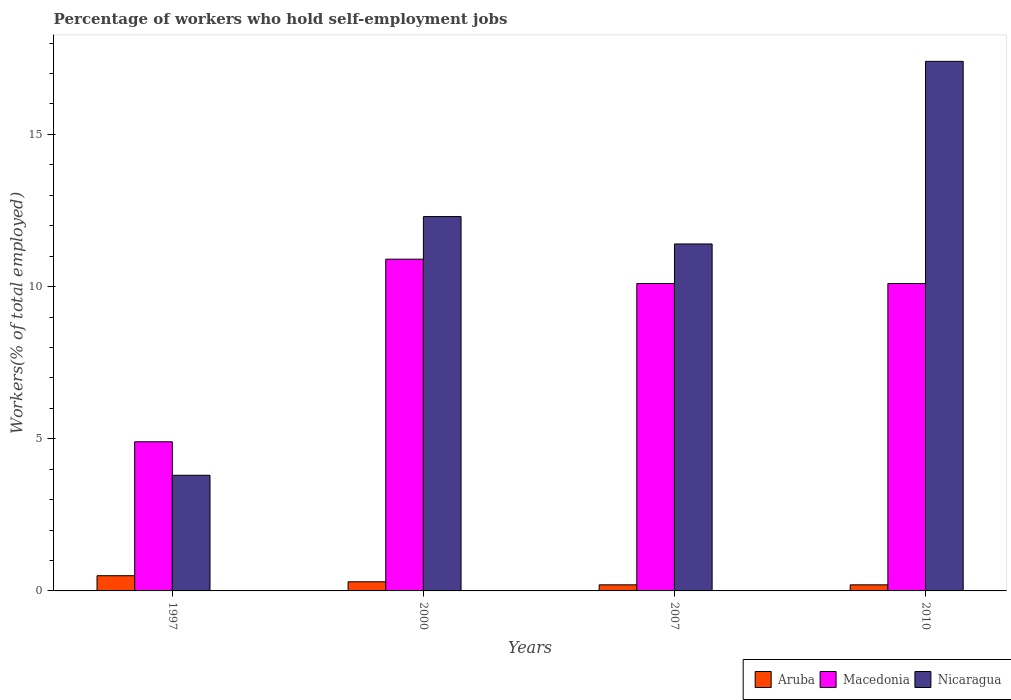How many different coloured bars are there?
Offer a terse response. 3. Are the number of bars per tick equal to the number of legend labels?
Your answer should be very brief. Yes. How many bars are there on the 1st tick from the right?
Your answer should be compact. 3. What is the label of the 3rd group of bars from the left?
Give a very brief answer. 2007. In how many cases, is the number of bars for a given year not equal to the number of legend labels?
Offer a very short reply. 0. What is the percentage of self-employed workers in Macedonia in 2000?
Give a very brief answer. 10.9. Across all years, what is the maximum percentage of self-employed workers in Macedonia?
Provide a short and direct response. 10.9. Across all years, what is the minimum percentage of self-employed workers in Aruba?
Offer a terse response. 0.2. What is the total percentage of self-employed workers in Nicaragua in the graph?
Your answer should be very brief. 44.9. What is the difference between the percentage of self-employed workers in Aruba in 2000 and that in 2010?
Your answer should be compact. 0.1. What is the difference between the percentage of self-employed workers in Nicaragua in 2007 and the percentage of self-employed workers in Aruba in 2000?
Your answer should be very brief. 11.1. What is the average percentage of self-employed workers in Aruba per year?
Provide a succinct answer. 0.3. In the year 2007, what is the difference between the percentage of self-employed workers in Nicaragua and percentage of self-employed workers in Macedonia?
Your response must be concise. 1.3. In how many years, is the percentage of self-employed workers in Macedonia greater than 5 %?
Make the answer very short. 3. What is the ratio of the percentage of self-employed workers in Nicaragua in 1997 to that in 2010?
Offer a very short reply. 0.22. Is the percentage of self-employed workers in Macedonia in 2000 less than that in 2007?
Offer a terse response. No. What is the difference between the highest and the second highest percentage of self-employed workers in Aruba?
Offer a terse response. 0.2. What is the difference between the highest and the lowest percentage of self-employed workers in Nicaragua?
Offer a very short reply. 13.6. What does the 1st bar from the left in 2010 represents?
Provide a short and direct response. Aruba. What does the 2nd bar from the right in 1997 represents?
Your answer should be compact. Macedonia. Does the graph contain grids?
Offer a very short reply. No. Where does the legend appear in the graph?
Give a very brief answer. Bottom right. What is the title of the graph?
Offer a very short reply. Percentage of workers who hold self-employment jobs. What is the label or title of the X-axis?
Make the answer very short. Years. What is the label or title of the Y-axis?
Offer a terse response. Workers(% of total employed). What is the Workers(% of total employed) of Aruba in 1997?
Make the answer very short. 0.5. What is the Workers(% of total employed) in Macedonia in 1997?
Keep it short and to the point. 4.9. What is the Workers(% of total employed) of Nicaragua in 1997?
Your answer should be very brief. 3.8. What is the Workers(% of total employed) in Aruba in 2000?
Your answer should be very brief. 0.3. What is the Workers(% of total employed) of Macedonia in 2000?
Provide a succinct answer. 10.9. What is the Workers(% of total employed) of Nicaragua in 2000?
Your answer should be compact. 12.3. What is the Workers(% of total employed) in Aruba in 2007?
Make the answer very short. 0.2. What is the Workers(% of total employed) in Macedonia in 2007?
Offer a terse response. 10.1. What is the Workers(% of total employed) of Nicaragua in 2007?
Your response must be concise. 11.4. What is the Workers(% of total employed) of Aruba in 2010?
Provide a succinct answer. 0.2. What is the Workers(% of total employed) in Macedonia in 2010?
Provide a succinct answer. 10.1. What is the Workers(% of total employed) of Nicaragua in 2010?
Give a very brief answer. 17.4. Across all years, what is the maximum Workers(% of total employed) of Macedonia?
Keep it short and to the point. 10.9. Across all years, what is the maximum Workers(% of total employed) in Nicaragua?
Ensure brevity in your answer.  17.4. Across all years, what is the minimum Workers(% of total employed) in Aruba?
Make the answer very short. 0.2. Across all years, what is the minimum Workers(% of total employed) in Macedonia?
Your answer should be compact. 4.9. Across all years, what is the minimum Workers(% of total employed) in Nicaragua?
Ensure brevity in your answer.  3.8. What is the total Workers(% of total employed) of Nicaragua in the graph?
Offer a very short reply. 44.9. What is the difference between the Workers(% of total employed) in Nicaragua in 1997 and that in 2000?
Provide a short and direct response. -8.5. What is the difference between the Workers(% of total employed) of Aruba in 1997 and that in 2007?
Make the answer very short. 0.3. What is the difference between the Workers(% of total employed) of Macedonia in 1997 and that in 2007?
Your response must be concise. -5.2. What is the difference between the Workers(% of total employed) in Nicaragua in 1997 and that in 2007?
Make the answer very short. -7.6. What is the difference between the Workers(% of total employed) of Aruba in 1997 and that in 2010?
Provide a succinct answer. 0.3. What is the difference between the Workers(% of total employed) of Nicaragua in 2000 and that in 2007?
Your answer should be compact. 0.9. What is the difference between the Workers(% of total employed) in Aruba in 2000 and that in 2010?
Your response must be concise. 0.1. What is the difference between the Workers(% of total employed) in Macedonia in 2000 and that in 2010?
Your response must be concise. 0.8. What is the difference between the Workers(% of total employed) in Aruba in 2007 and that in 2010?
Keep it short and to the point. 0. What is the difference between the Workers(% of total employed) of Macedonia in 2007 and that in 2010?
Provide a succinct answer. 0. What is the difference between the Workers(% of total employed) in Nicaragua in 2007 and that in 2010?
Your answer should be very brief. -6. What is the difference between the Workers(% of total employed) in Aruba in 1997 and the Workers(% of total employed) in Macedonia in 2000?
Give a very brief answer. -10.4. What is the difference between the Workers(% of total employed) in Macedonia in 1997 and the Workers(% of total employed) in Nicaragua in 2000?
Offer a terse response. -7.4. What is the difference between the Workers(% of total employed) of Aruba in 1997 and the Workers(% of total employed) of Macedonia in 2007?
Keep it short and to the point. -9.6. What is the difference between the Workers(% of total employed) of Aruba in 1997 and the Workers(% of total employed) of Nicaragua in 2010?
Keep it short and to the point. -16.9. What is the difference between the Workers(% of total employed) of Aruba in 2000 and the Workers(% of total employed) of Macedonia in 2010?
Give a very brief answer. -9.8. What is the difference between the Workers(% of total employed) of Aruba in 2000 and the Workers(% of total employed) of Nicaragua in 2010?
Ensure brevity in your answer.  -17.1. What is the difference between the Workers(% of total employed) in Aruba in 2007 and the Workers(% of total employed) in Macedonia in 2010?
Your answer should be compact. -9.9. What is the difference between the Workers(% of total employed) of Aruba in 2007 and the Workers(% of total employed) of Nicaragua in 2010?
Keep it short and to the point. -17.2. What is the difference between the Workers(% of total employed) of Macedonia in 2007 and the Workers(% of total employed) of Nicaragua in 2010?
Ensure brevity in your answer.  -7.3. What is the average Workers(% of total employed) of Aruba per year?
Ensure brevity in your answer.  0.3. What is the average Workers(% of total employed) of Nicaragua per year?
Provide a succinct answer. 11.22. In the year 1997, what is the difference between the Workers(% of total employed) in Aruba and Workers(% of total employed) in Macedonia?
Offer a terse response. -4.4. In the year 1997, what is the difference between the Workers(% of total employed) in Aruba and Workers(% of total employed) in Nicaragua?
Give a very brief answer. -3.3. In the year 1997, what is the difference between the Workers(% of total employed) of Macedonia and Workers(% of total employed) of Nicaragua?
Offer a very short reply. 1.1. In the year 2000, what is the difference between the Workers(% of total employed) in Aruba and Workers(% of total employed) in Macedonia?
Ensure brevity in your answer.  -10.6. In the year 2000, what is the difference between the Workers(% of total employed) of Aruba and Workers(% of total employed) of Nicaragua?
Offer a terse response. -12. In the year 2000, what is the difference between the Workers(% of total employed) of Macedonia and Workers(% of total employed) of Nicaragua?
Ensure brevity in your answer.  -1.4. In the year 2007, what is the difference between the Workers(% of total employed) of Aruba and Workers(% of total employed) of Nicaragua?
Provide a short and direct response. -11.2. In the year 2007, what is the difference between the Workers(% of total employed) of Macedonia and Workers(% of total employed) of Nicaragua?
Your response must be concise. -1.3. In the year 2010, what is the difference between the Workers(% of total employed) of Aruba and Workers(% of total employed) of Nicaragua?
Keep it short and to the point. -17.2. In the year 2010, what is the difference between the Workers(% of total employed) in Macedonia and Workers(% of total employed) in Nicaragua?
Offer a very short reply. -7.3. What is the ratio of the Workers(% of total employed) of Aruba in 1997 to that in 2000?
Your answer should be very brief. 1.67. What is the ratio of the Workers(% of total employed) in Macedonia in 1997 to that in 2000?
Your answer should be very brief. 0.45. What is the ratio of the Workers(% of total employed) in Nicaragua in 1997 to that in 2000?
Offer a very short reply. 0.31. What is the ratio of the Workers(% of total employed) of Macedonia in 1997 to that in 2007?
Ensure brevity in your answer.  0.49. What is the ratio of the Workers(% of total employed) of Nicaragua in 1997 to that in 2007?
Provide a short and direct response. 0.33. What is the ratio of the Workers(% of total employed) of Macedonia in 1997 to that in 2010?
Make the answer very short. 0.49. What is the ratio of the Workers(% of total employed) of Nicaragua in 1997 to that in 2010?
Ensure brevity in your answer.  0.22. What is the ratio of the Workers(% of total employed) in Aruba in 2000 to that in 2007?
Offer a very short reply. 1.5. What is the ratio of the Workers(% of total employed) in Macedonia in 2000 to that in 2007?
Provide a short and direct response. 1.08. What is the ratio of the Workers(% of total employed) of Nicaragua in 2000 to that in 2007?
Offer a very short reply. 1.08. What is the ratio of the Workers(% of total employed) of Aruba in 2000 to that in 2010?
Give a very brief answer. 1.5. What is the ratio of the Workers(% of total employed) of Macedonia in 2000 to that in 2010?
Keep it short and to the point. 1.08. What is the ratio of the Workers(% of total employed) in Nicaragua in 2000 to that in 2010?
Provide a short and direct response. 0.71. What is the ratio of the Workers(% of total employed) in Aruba in 2007 to that in 2010?
Offer a very short reply. 1. What is the ratio of the Workers(% of total employed) in Nicaragua in 2007 to that in 2010?
Your answer should be very brief. 0.66. What is the difference between the highest and the second highest Workers(% of total employed) in Aruba?
Give a very brief answer. 0.2. What is the difference between the highest and the second highest Workers(% of total employed) in Macedonia?
Offer a terse response. 0.8. What is the difference between the highest and the second highest Workers(% of total employed) in Nicaragua?
Offer a terse response. 5.1. What is the difference between the highest and the lowest Workers(% of total employed) in Aruba?
Your answer should be very brief. 0.3. What is the difference between the highest and the lowest Workers(% of total employed) of Nicaragua?
Keep it short and to the point. 13.6. 